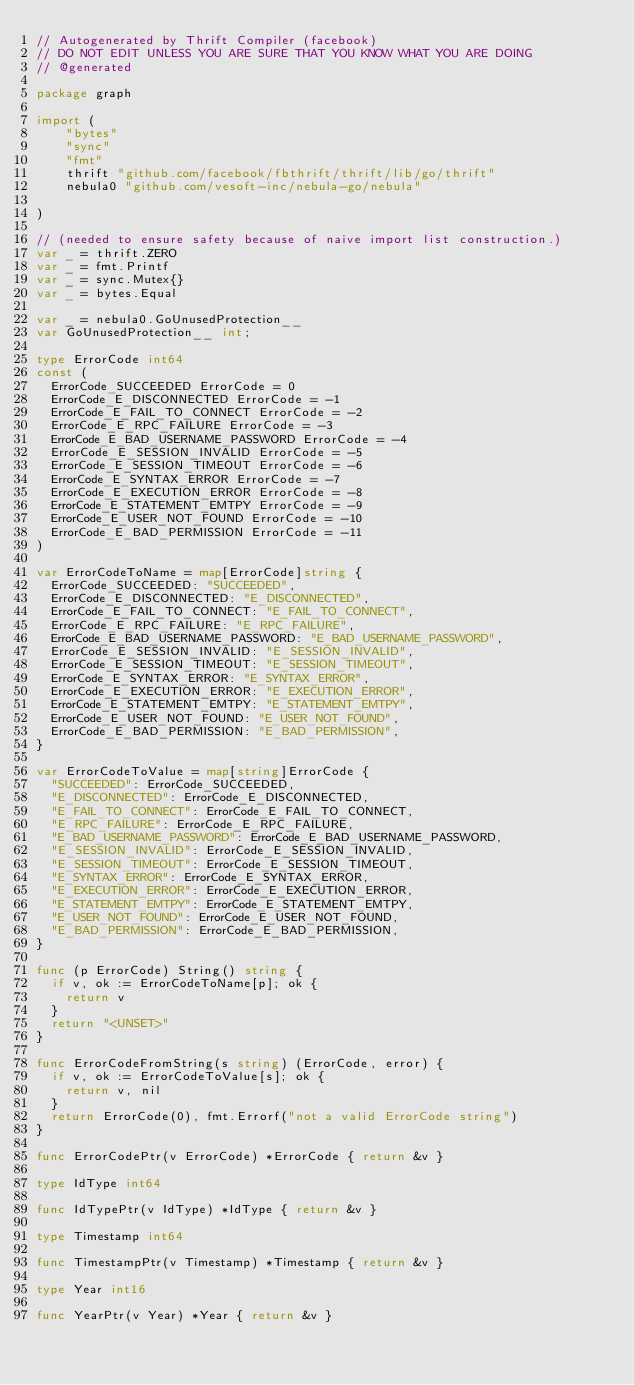<code> <loc_0><loc_0><loc_500><loc_500><_Go_>// Autogenerated by Thrift Compiler (facebook)
// DO NOT EDIT UNLESS YOU ARE SURE THAT YOU KNOW WHAT YOU ARE DOING
// @generated

package graph

import (
	"bytes"
	"sync"
	"fmt"
	thrift "github.com/facebook/fbthrift/thrift/lib/go/thrift"
	nebula0 "github.com/vesoft-inc/nebula-go/nebula"

)

// (needed to ensure safety because of naive import list construction.)
var _ = thrift.ZERO
var _ = fmt.Printf
var _ = sync.Mutex{}
var _ = bytes.Equal

var _ = nebula0.GoUnusedProtection__
var GoUnusedProtection__ int;

type ErrorCode int64
const (
  ErrorCode_SUCCEEDED ErrorCode = 0
  ErrorCode_E_DISCONNECTED ErrorCode = -1
  ErrorCode_E_FAIL_TO_CONNECT ErrorCode = -2
  ErrorCode_E_RPC_FAILURE ErrorCode = -3
  ErrorCode_E_BAD_USERNAME_PASSWORD ErrorCode = -4
  ErrorCode_E_SESSION_INVALID ErrorCode = -5
  ErrorCode_E_SESSION_TIMEOUT ErrorCode = -6
  ErrorCode_E_SYNTAX_ERROR ErrorCode = -7
  ErrorCode_E_EXECUTION_ERROR ErrorCode = -8
  ErrorCode_E_STATEMENT_EMTPY ErrorCode = -9
  ErrorCode_E_USER_NOT_FOUND ErrorCode = -10
  ErrorCode_E_BAD_PERMISSION ErrorCode = -11
)

var ErrorCodeToName = map[ErrorCode]string {
  ErrorCode_SUCCEEDED: "SUCCEEDED",
  ErrorCode_E_DISCONNECTED: "E_DISCONNECTED",
  ErrorCode_E_FAIL_TO_CONNECT: "E_FAIL_TO_CONNECT",
  ErrorCode_E_RPC_FAILURE: "E_RPC_FAILURE",
  ErrorCode_E_BAD_USERNAME_PASSWORD: "E_BAD_USERNAME_PASSWORD",
  ErrorCode_E_SESSION_INVALID: "E_SESSION_INVALID",
  ErrorCode_E_SESSION_TIMEOUT: "E_SESSION_TIMEOUT",
  ErrorCode_E_SYNTAX_ERROR: "E_SYNTAX_ERROR",
  ErrorCode_E_EXECUTION_ERROR: "E_EXECUTION_ERROR",
  ErrorCode_E_STATEMENT_EMTPY: "E_STATEMENT_EMTPY",
  ErrorCode_E_USER_NOT_FOUND: "E_USER_NOT_FOUND",
  ErrorCode_E_BAD_PERMISSION: "E_BAD_PERMISSION",
}

var ErrorCodeToValue = map[string]ErrorCode {
  "SUCCEEDED": ErrorCode_SUCCEEDED,
  "E_DISCONNECTED": ErrorCode_E_DISCONNECTED,
  "E_FAIL_TO_CONNECT": ErrorCode_E_FAIL_TO_CONNECT,
  "E_RPC_FAILURE": ErrorCode_E_RPC_FAILURE,
  "E_BAD_USERNAME_PASSWORD": ErrorCode_E_BAD_USERNAME_PASSWORD,
  "E_SESSION_INVALID": ErrorCode_E_SESSION_INVALID,
  "E_SESSION_TIMEOUT": ErrorCode_E_SESSION_TIMEOUT,
  "E_SYNTAX_ERROR": ErrorCode_E_SYNTAX_ERROR,
  "E_EXECUTION_ERROR": ErrorCode_E_EXECUTION_ERROR,
  "E_STATEMENT_EMTPY": ErrorCode_E_STATEMENT_EMTPY,
  "E_USER_NOT_FOUND": ErrorCode_E_USER_NOT_FOUND,
  "E_BAD_PERMISSION": ErrorCode_E_BAD_PERMISSION,
}

func (p ErrorCode) String() string {
  if v, ok := ErrorCodeToName[p]; ok {
    return v
  }
  return "<UNSET>"
}

func ErrorCodeFromString(s string) (ErrorCode, error) {
  if v, ok := ErrorCodeToValue[s]; ok {
    return v, nil
  }
  return ErrorCode(0), fmt.Errorf("not a valid ErrorCode string")
}

func ErrorCodePtr(v ErrorCode) *ErrorCode { return &v }

type IdType int64

func IdTypePtr(v IdType) *IdType { return &v }

type Timestamp int64

func TimestampPtr(v Timestamp) *Timestamp { return &v }

type Year int16

func YearPtr(v Year) *Year { return &v }
</code> 